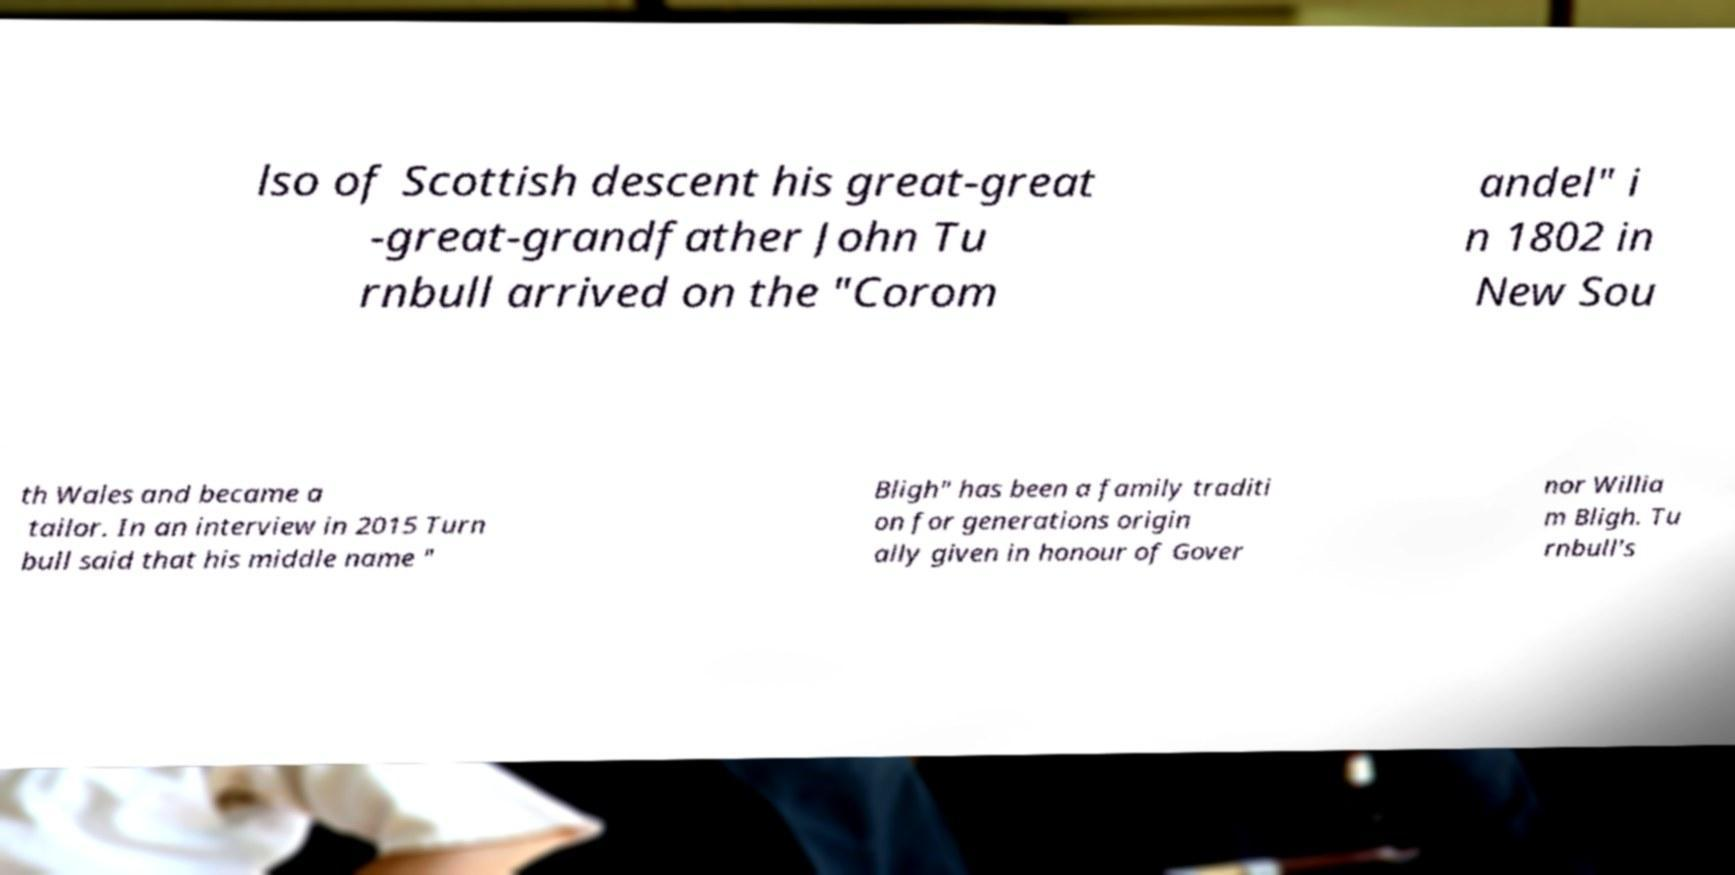Can you read and provide the text displayed in the image?This photo seems to have some interesting text. Can you extract and type it out for me? lso of Scottish descent his great-great -great-grandfather John Tu rnbull arrived on the "Corom andel" i n 1802 in New Sou th Wales and became a tailor. In an interview in 2015 Turn bull said that his middle name " Bligh" has been a family traditi on for generations origin ally given in honour of Gover nor Willia m Bligh. Tu rnbull's 